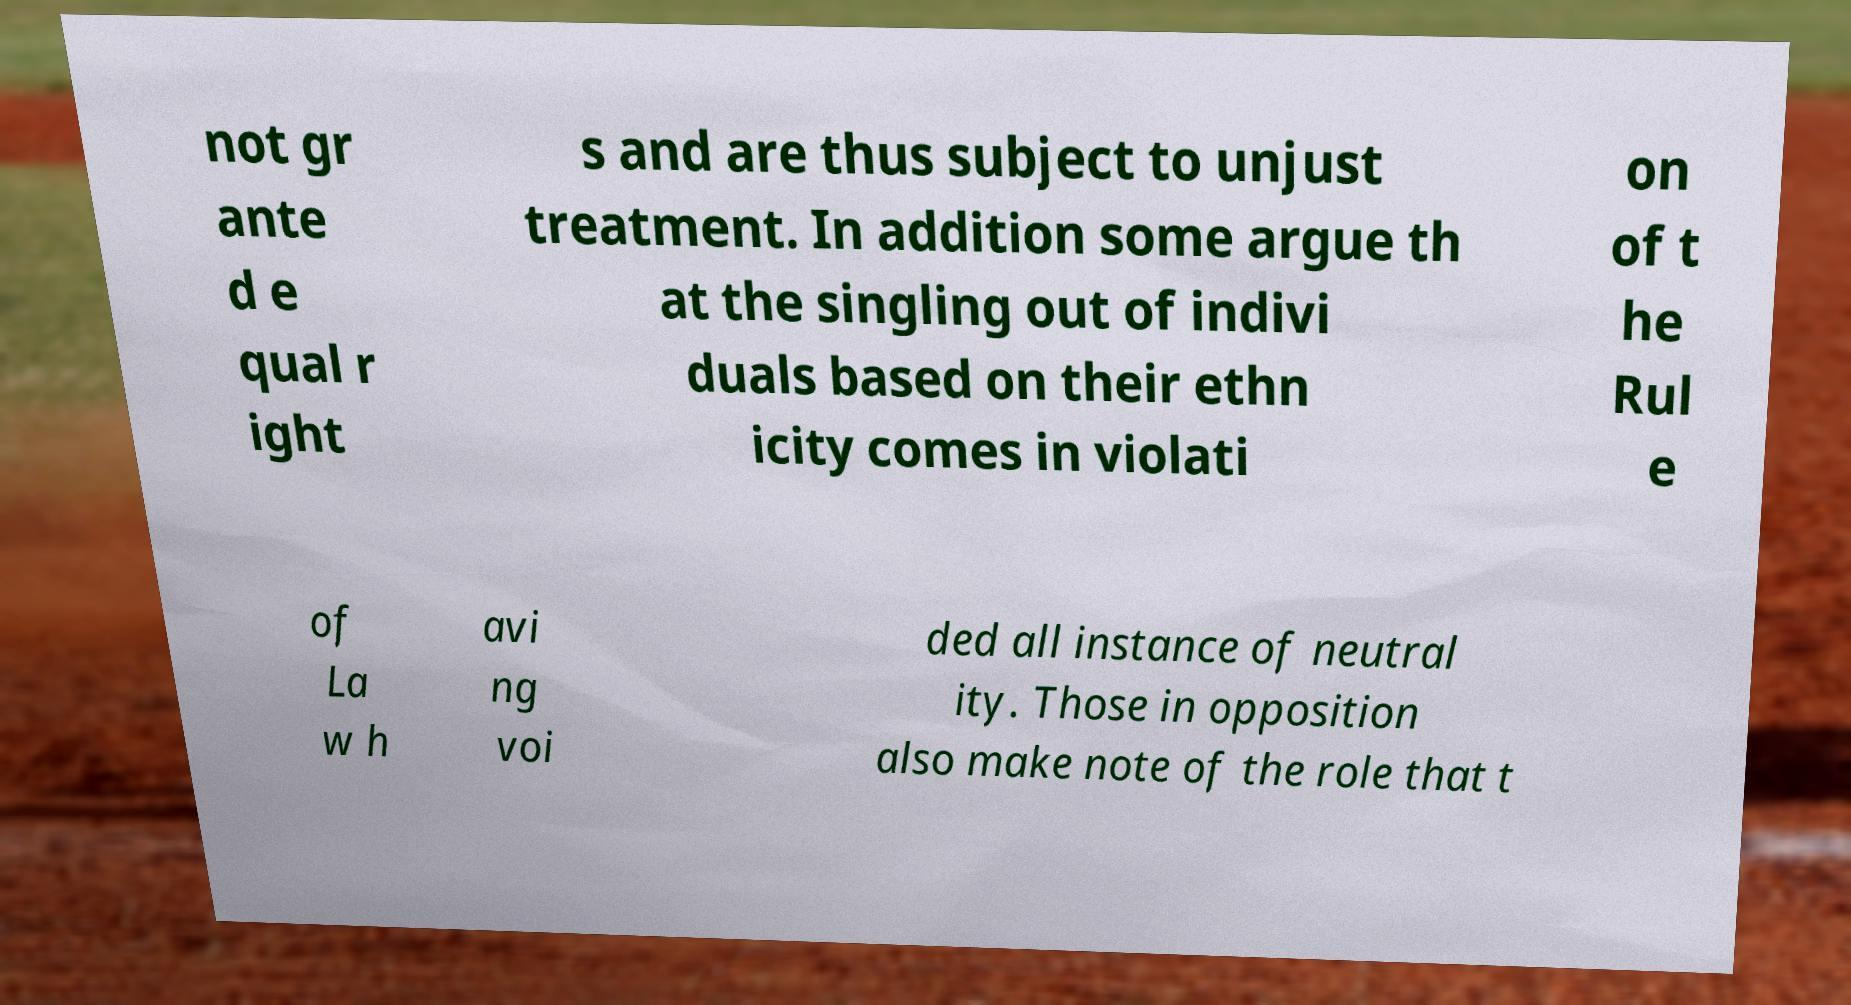Could you extract and type out the text from this image? not gr ante d e qual r ight s and are thus subject to unjust treatment. In addition some argue th at the singling out of indivi duals based on their ethn icity comes in violati on of t he Rul e of La w h avi ng voi ded all instance of neutral ity. Those in opposition also make note of the role that t 